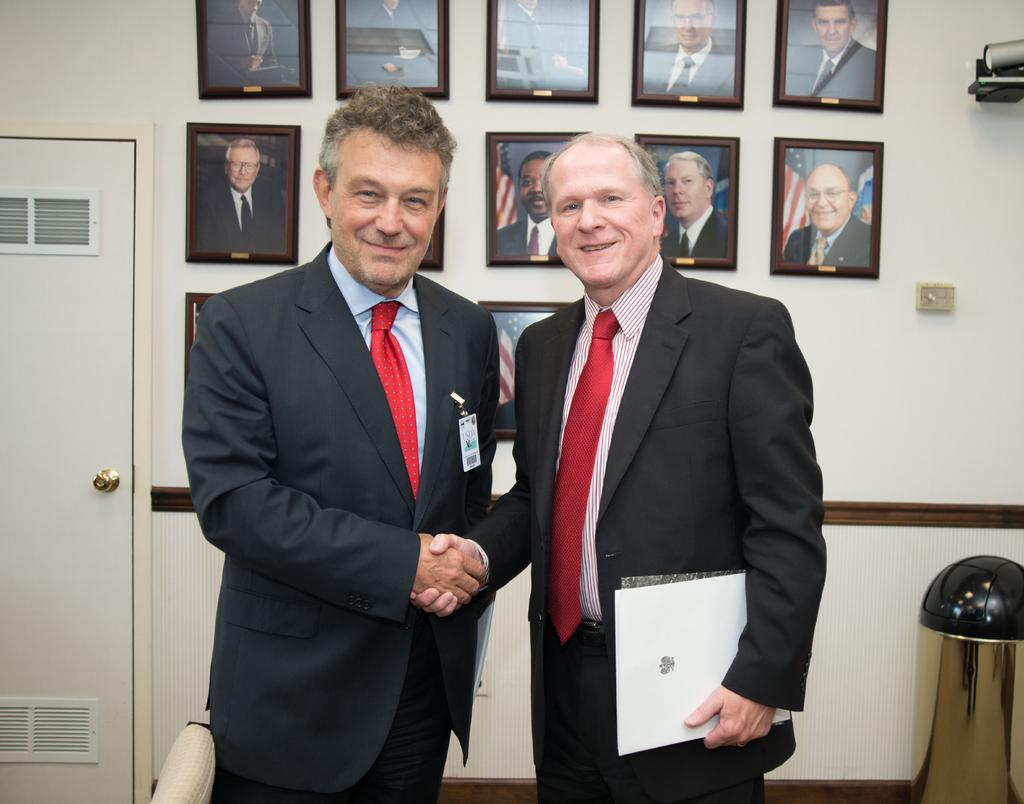What are the people in the image doing? The persons standing on the floor in the image are likely standing or posing for the photo. What can be seen in the background of the image? In the background of the image, there are photo frames, a door, a dustbin, and a wall. Can you describe the door in the background? The door in the background is a standard door, likely leading to another room or area. What might be used for disposing of waste in the image? The dustbin in the background can be used for disposing of waste. How does the sponge help the person in the image? There is no sponge present in the image, so it cannot help the person in any way. 